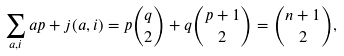<formula> <loc_0><loc_0><loc_500><loc_500>\sum _ { a , i } a p + j ( a , i ) = p \binom { q } { 2 } + q \binom { p + 1 } { 2 } = \binom { n + 1 } { 2 } ,</formula> 